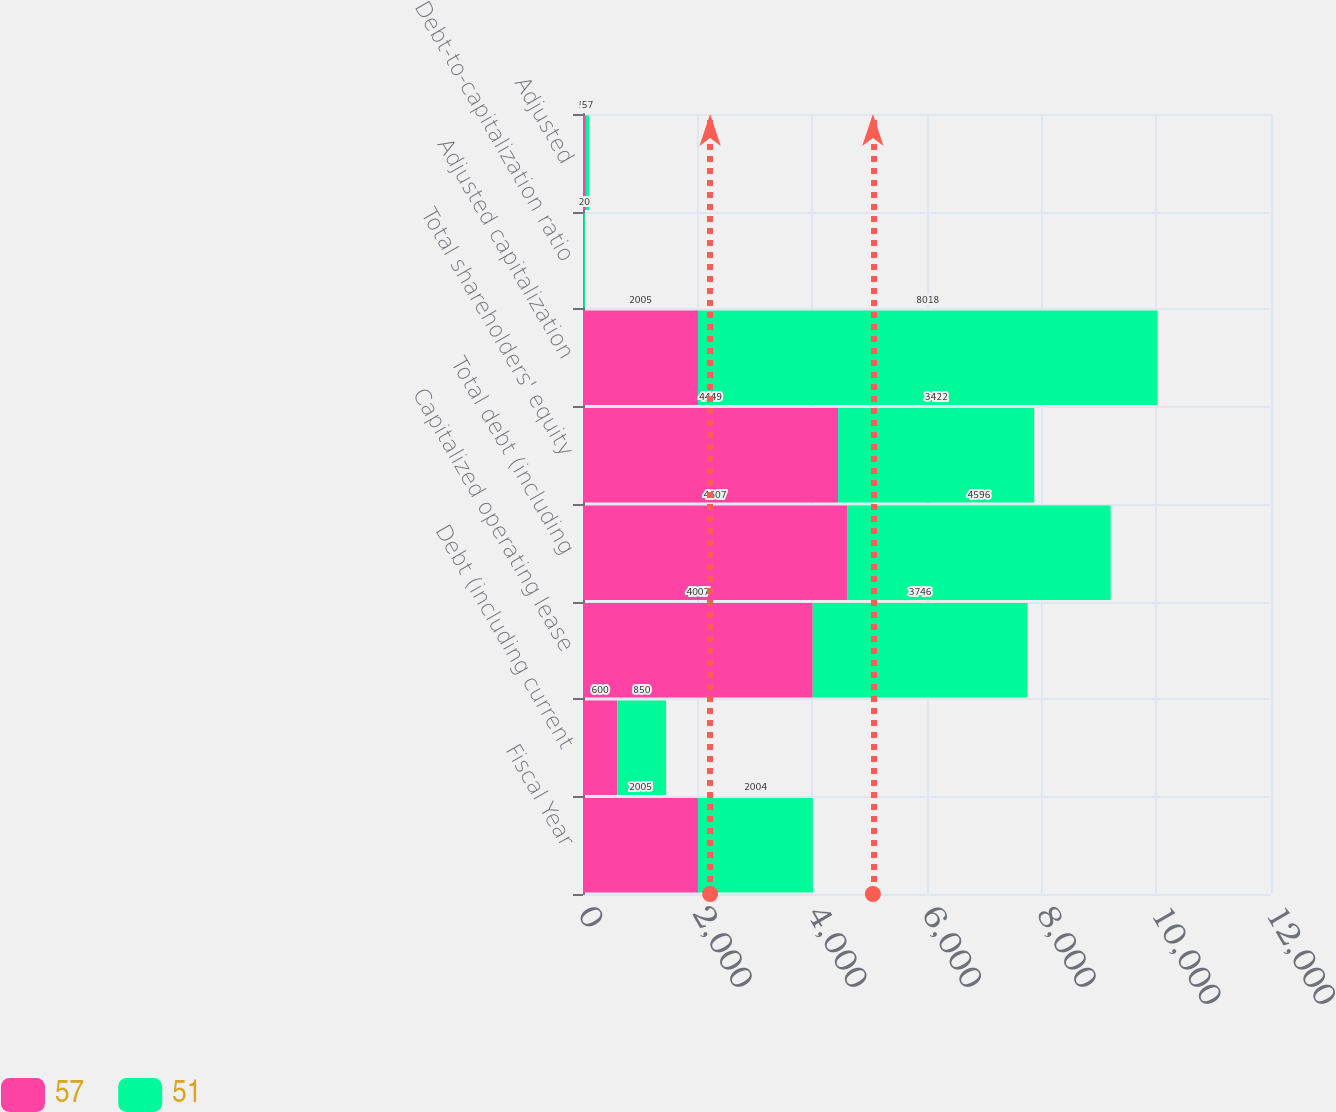<chart> <loc_0><loc_0><loc_500><loc_500><stacked_bar_chart><ecel><fcel>Fiscal Year<fcel>Debt (including current<fcel>Capitalized operating lease<fcel>Total debt (including<fcel>Total shareholders' equity<fcel>Adjusted capitalization<fcel>Debt-to-capitalization ratio<fcel>Adjusted<nl><fcel>57<fcel>2005<fcel>600<fcel>4007<fcel>4607<fcel>4449<fcel>2005<fcel>12<fcel>51<nl><fcel>51<fcel>2004<fcel>850<fcel>3746<fcel>4596<fcel>3422<fcel>8018<fcel>20<fcel>57<nl></chart> 